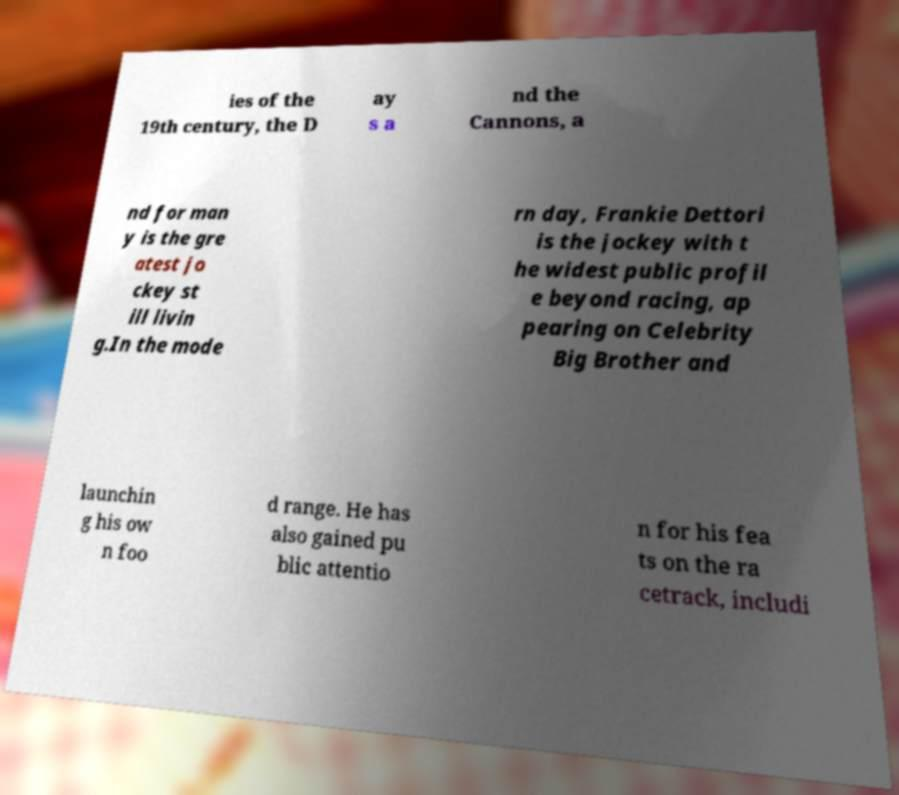There's text embedded in this image that I need extracted. Can you transcribe it verbatim? ies of the 19th century, the D ay s a nd the Cannons, a nd for man y is the gre atest jo ckey st ill livin g.In the mode rn day, Frankie Dettori is the jockey with t he widest public profil e beyond racing, ap pearing on Celebrity Big Brother and launchin g his ow n foo d range. He has also gained pu blic attentio n for his fea ts on the ra cetrack, includi 